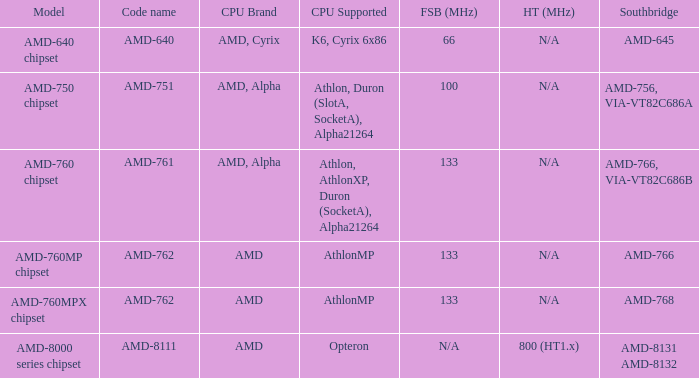What is the Southbridge when the CPU support was athlon, athlonxp, duron( socketa ), alpha21264? AMD-766, VIA-VT82C686B. Would you mind parsing the complete table? {'header': ['Model', 'Code name', 'CPU Brand', 'CPU Supported', 'FSB (MHz)', 'HT (MHz)', 'Southbridge'], 'rows': [['AMD-640 chipset', 'AMD-640', 'AMD, Cyrix', 'K6, Cyrix 6x86', '66', 'N/A', 'AMD-645'], ['AMD-750 chipset', 'AMD-751', 'AMD, Alpha', 'Athlon, Duron (SlotA, SocketA), Alpha21264', '100', 'N/A', 'AMD-756, VIA-VT82C686A'], ['AMD-760 chipset', 'AMD-761', 'AMD, Alpha', 'Athlon, AthlonXP, Duron (SocketA), Alpha21264', '133', 'N/A', 'AMD-766, VIA-VT82C686B'], ['AMD-760MP chipset', 'AMD-762', 'AMD', 'AthlonMP', '133', 'N/A', 'AMD-766'], ['AMD-760MPX chipset', 'AMD-762', 'AMD', 'AthlonMP', '133', 'N/A', 'AMD-768'], ['AMD-8000 series chipset', 'AMD-8111', 'AMD', 'Opteron', 'N/A', '800 (HT1.x)', 'AMD-8131 AMD-8132']]} 